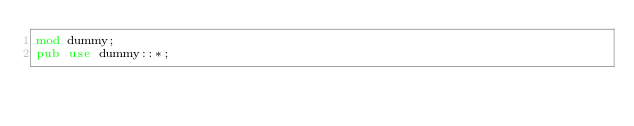<code> <loc_0><loc_0><loc_500><loc_500><_Rust_>mod dummy;
pub use dummy::*;

</code> 